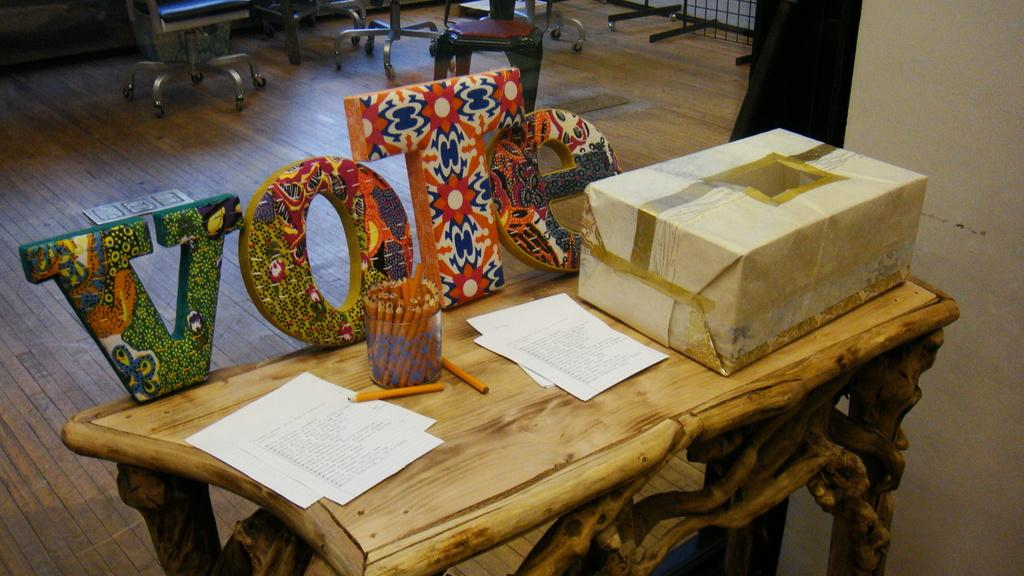What piece of furniture is present in the image? There is a table in the image. What object is placed on the table? There is a box on the table. What type of seating is visible on the floor? There are stools on the floor. What type of attraction can be seen in the background of the image? There is no attraction visible in the image; it only features a table, a box, and stools. What type of breakfast is being served on the table in the image? There is no breakfast visible in the image; it only features a table, a box, and stools. 